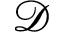<formula> <loc_0><loc_0><loc_500><loc_500>\mathcal { D }</formula> 